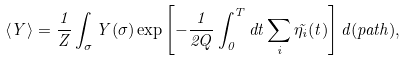<formula> <loc_0><loc_0><loc_500><loc_500>\langle Y \rangle = \frac { 1 } { Z } \int _ { \sigma } Y ( \sigma ) \exp \left [ - \frac { 1 } { 2 Q } \int _ { 0 } ^ { T } d t \sum _ { i } \tilde { \eta _ { i } } ( t ) \right ] d ( p a t h ) ,</formula> 